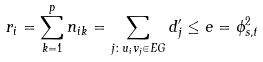Convert formula to latex. <formula><loc_0><loc_0><loc_500><loc_500>r _ { i } = \sum _ { k = 1 } ^ { p } n _ { i k } = \sum _ { j \colon u _ { i } v _ { j } \in E G } d ^ { \prime } _ { j } \leq e = \phi ^ { 2 } _ { s , t }</formula> 